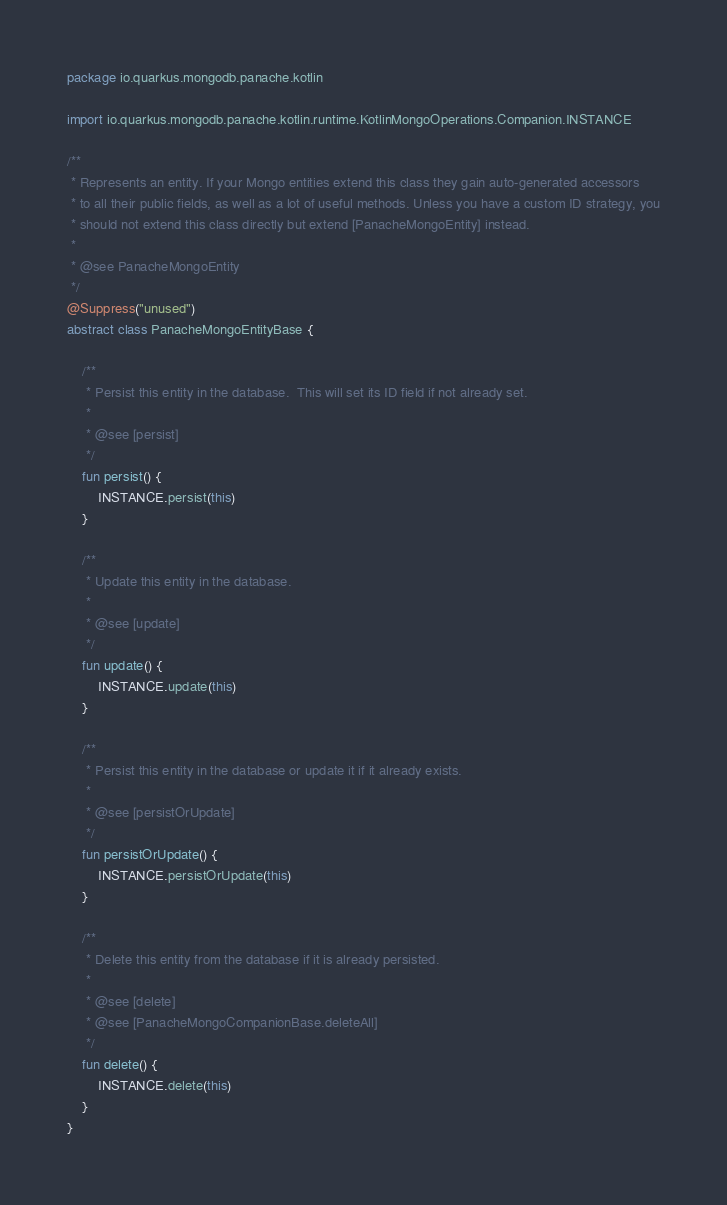Convert code to text. <code><loc_0><loc_0><loc_500><loc_500><_Kotlin_>package io.quarkus.mongodb.panache.kotlin

import io.quarkus.mongodb.panache.kotlin.runtime.KotlinMongoOperations.Companion.INSTANCE

/**
 * Represents an entity. If your Mongo entities extend this class they gain auto-generated accessors
 * to all their public fields, as well as a lot of useful methods. Unless you have a custom ID strategy, you
 * should not extend this class directly but extend [PanacheMongoEntity] instead.
 *
 * @see PanacheMongoEntity
 */
@Suppress("unused")
abstract class PanacheMongoEntityBase {

    /**
     * Persist this entity in the database.  This will set its ID field if not already set.
     *
     * @see [persist]
     */
    fun persist() {
        INSTANCE.persist(this)
    }

    /**
     * Update this entity in the database.
     *
     * @see [update]
     */
    fun update() {
        INSTANCE.update(this)
    }

    /**
     * Persist this entity in the database or update it if it already exists.
     *
     * @see [persistOrUpdate]
     */
    fun persistOrUpdate() {
        INSTANCE.persistOrUpdate(this)
    }

    /**
     * Delete this entity from the database if it is already persisted.
     *
     * @see [delete]
     * @see [PanacheMongoCompanionBase.deleteAll]
     */
    fun delete() {
        INSTANCE.delete(this)
    }
}</code> 